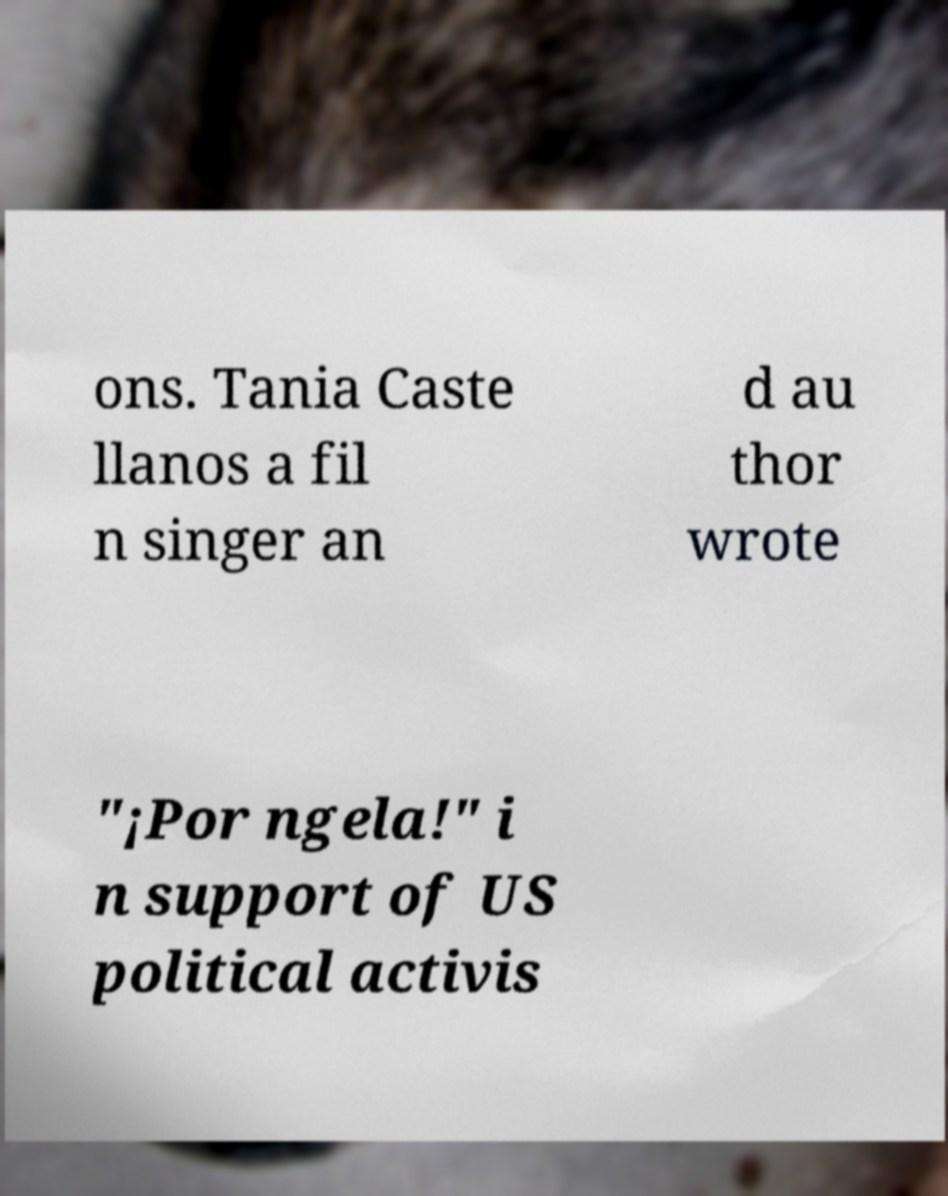I need the written content from this picture converted into text. Can you do that? ons. Tania Caste llanos a fil n singer an d au thor wrote "¡Por ngela!" i n support of US political activis 